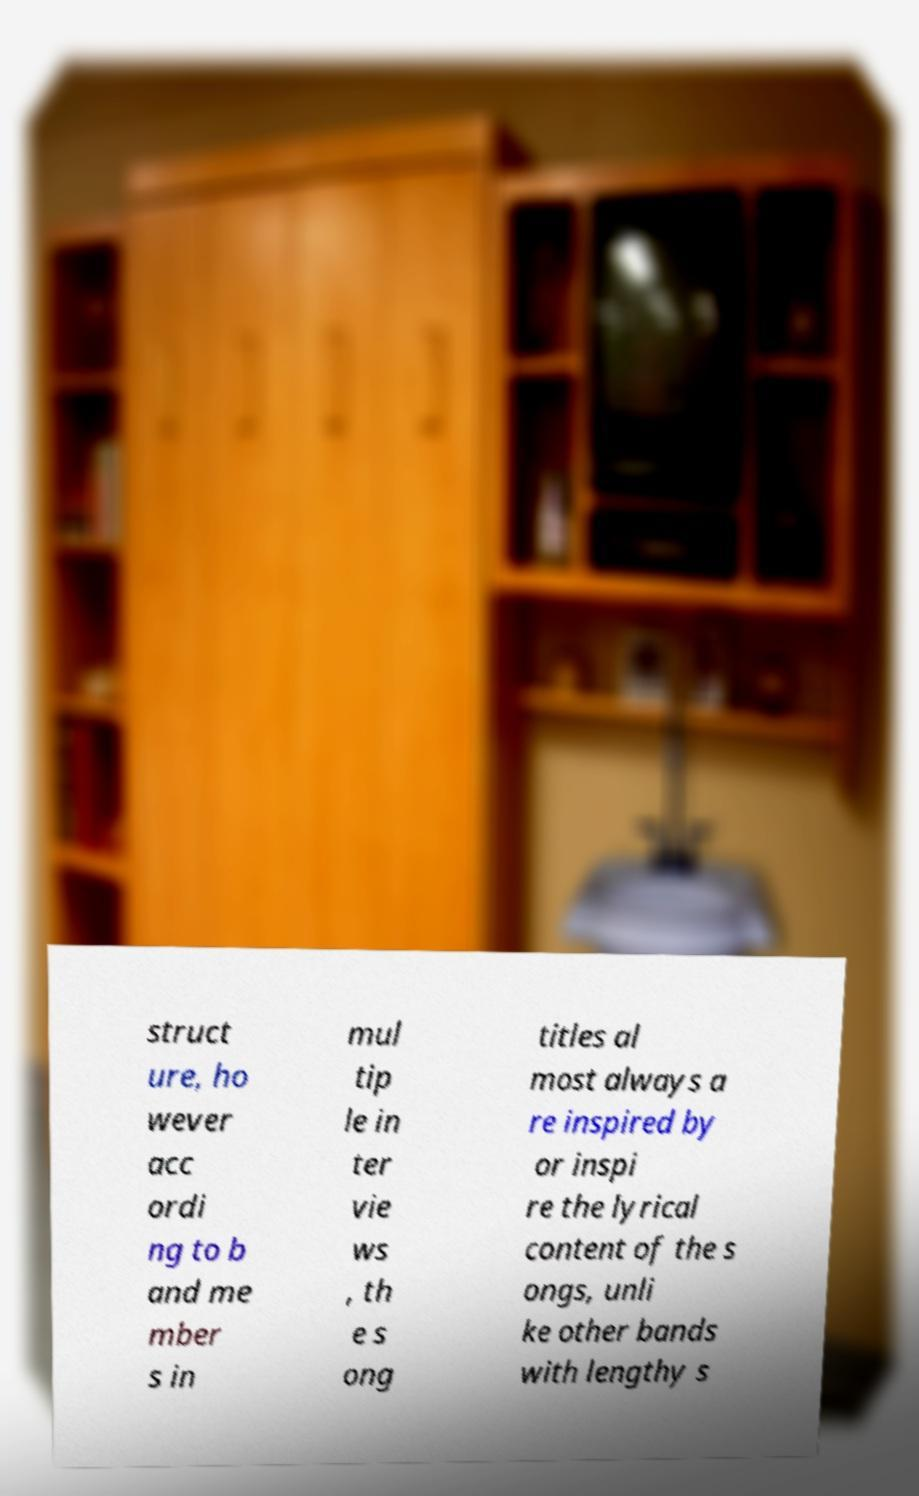Please identify and transcribe the text found in this image. struct ure, ho wever acc ordi ng to b and me mber s in mul tip le in ter vie ws , th e s ong titles al most always a re inspired by or inspi re the lyrical content of the s ongs, unli ke other bands with lengthy s 